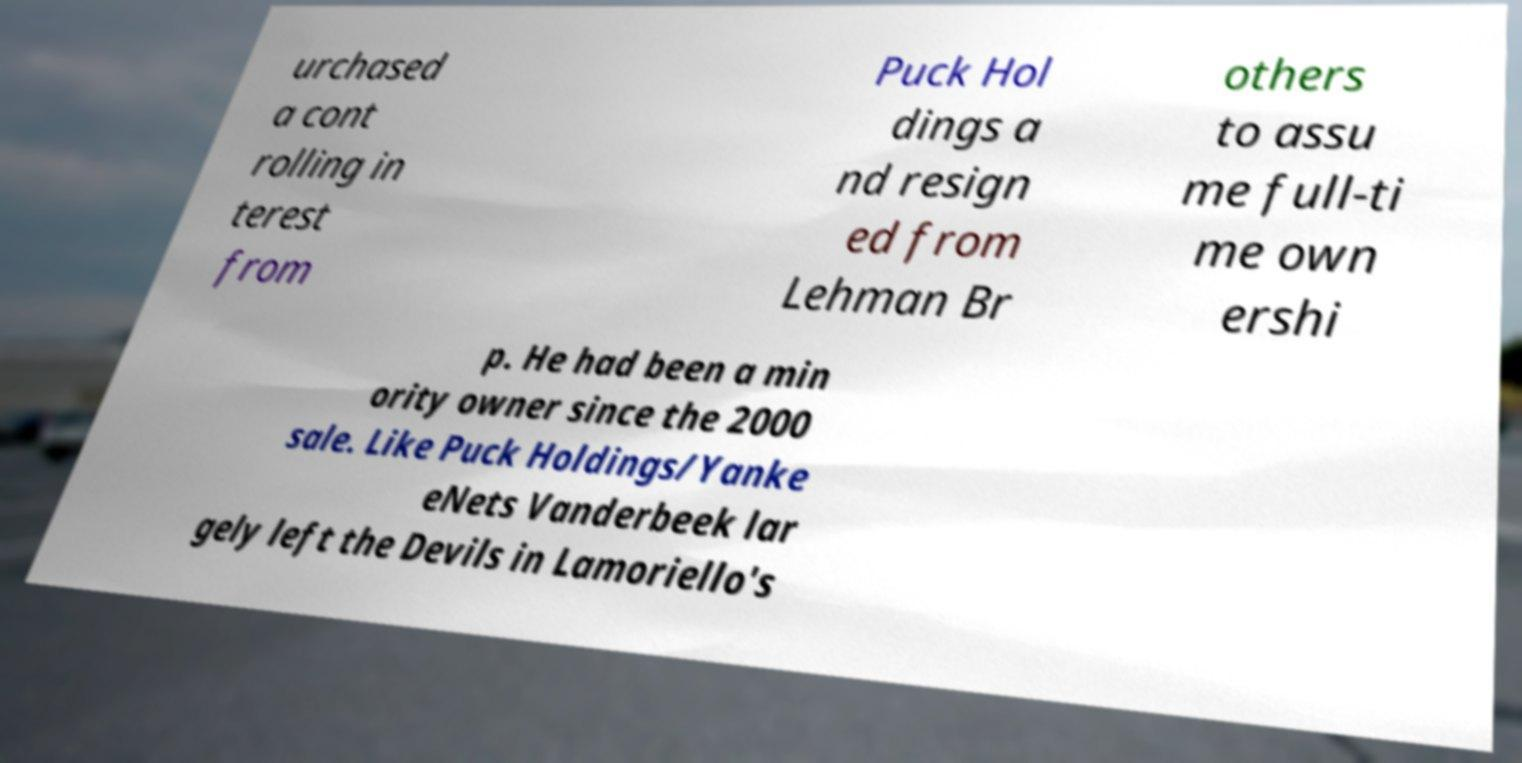Please identify and transcribe the text found in this image. urchased a cont rolling in terest from Puck Hol dings a nd resign ed from Lehman Br others to assu me full-ti me own ershi p. He had been a min ority owner since the 2000 sale. Like Puck Holdings/Yanke eNets Vanderbeek lar gely left the Devils in Lamoriello's 